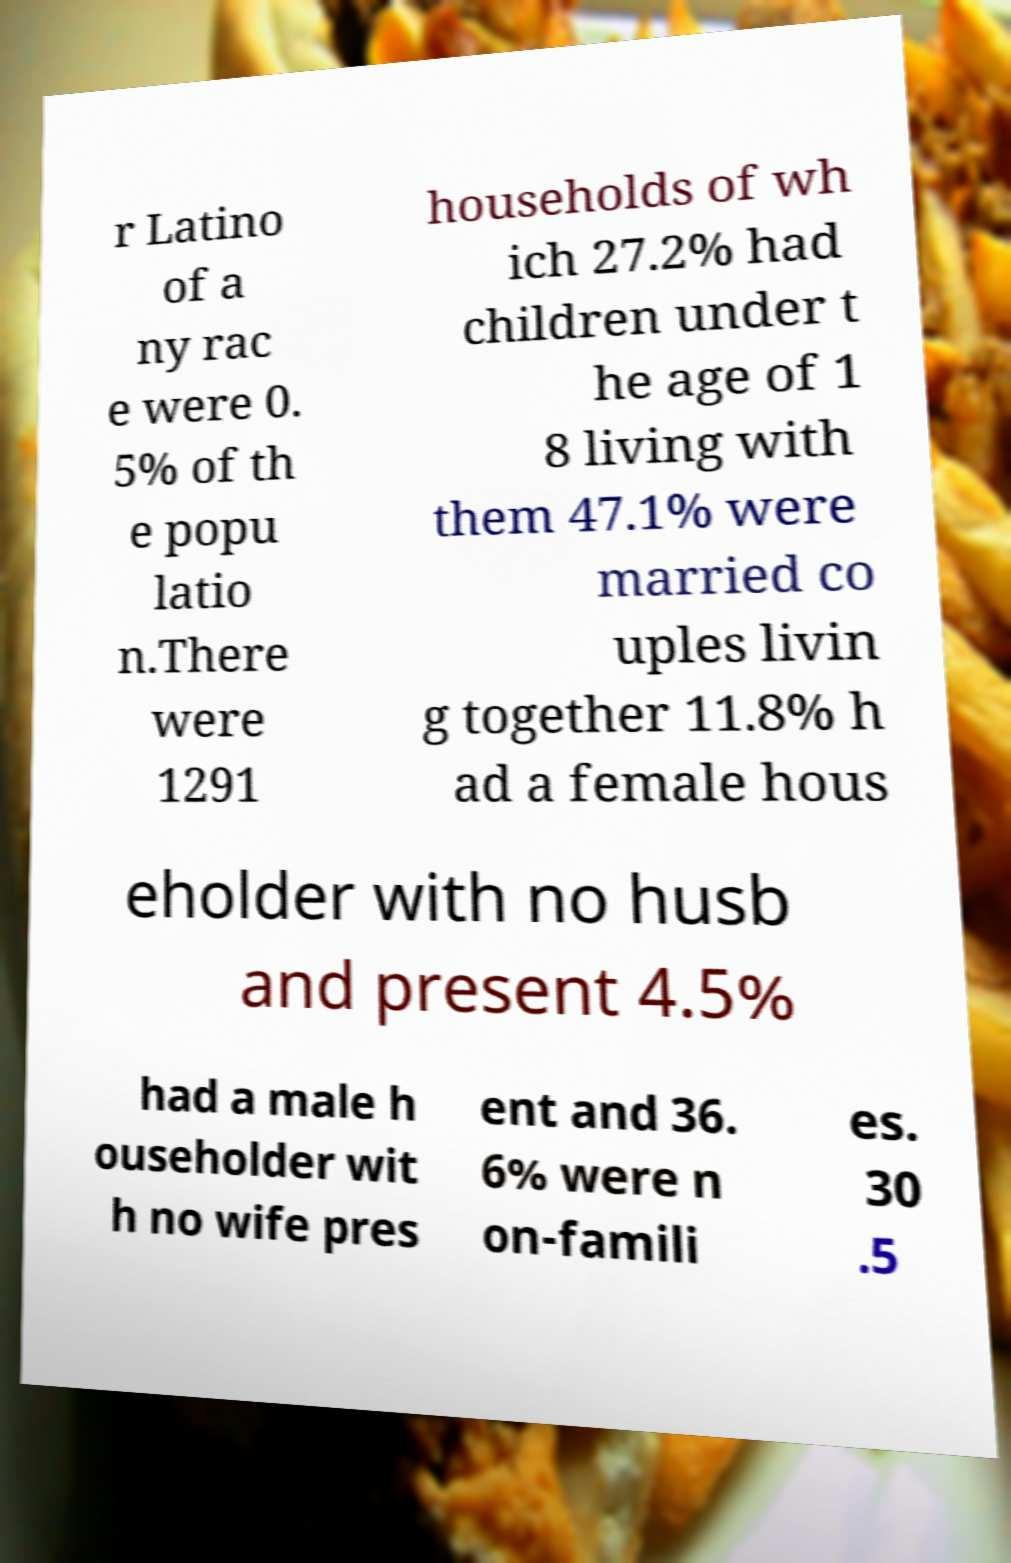Please identify and transcribe the text found in this image. r Latino of a ny rac e were 0. 5% of th e popu latio n.There were 1291 households of wh ich 27.2% had children under t he age of 1 8 living with them 47.1% were married co uples livin g together 11.8% h ad a female hous eholder with no husb and present 4.5% had a male h ouseholder wit h no wife pres ent and 36. 6% were n on-famili es. 30 .5 